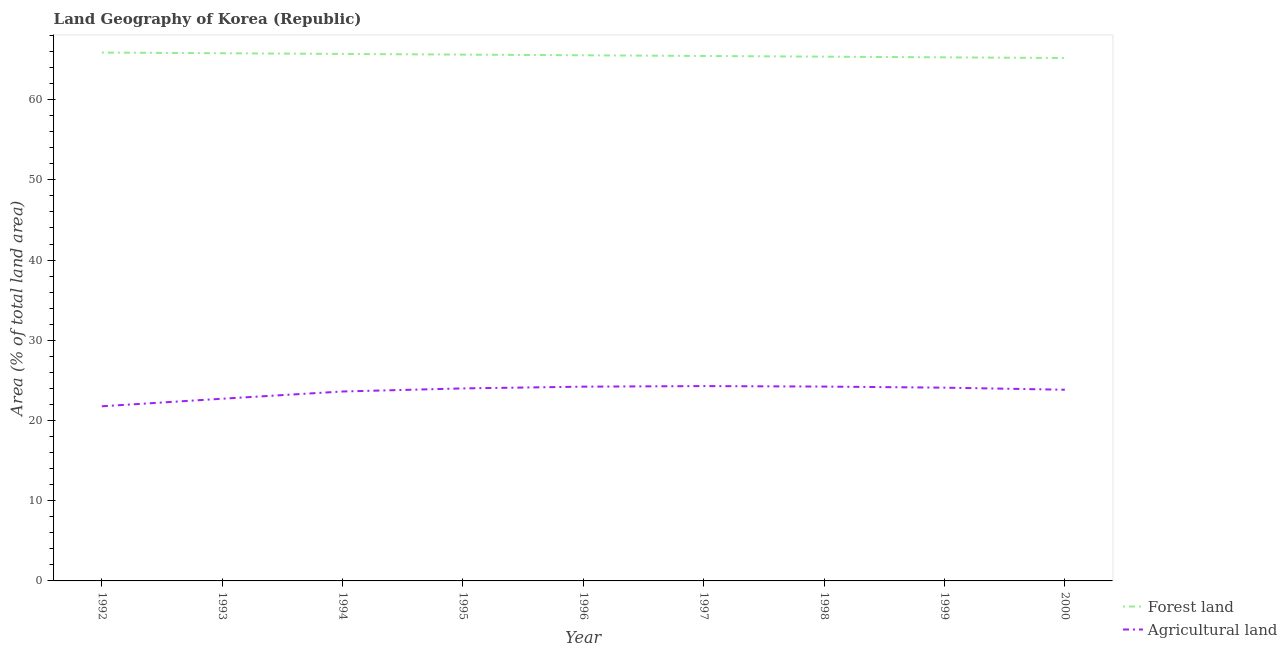How many different coloured lines are there?
Keep it short and to the point. 2. What is the percentage of land area under agriculture in 1994?
Provide a succinct answer. 23.62. Across all years, what is the maximum percentage of land area under forests?
Offer a terse response. 65.87. Across all years, what is the minimum percentage of land area under forests?
Ensure brevity in your answer.  65.19. In which year was the percentage of land area under agriculture minimum?
Your answer should be compact. 1992. What is the total percentage of land area under agriculture in the graph?
Offer a terse response. 212.76. What is the difference between the percentage of land area under agriculture in 1996 and that in 2000?
Ensure brevity in your answer.  0.38. What is the difference between the percentage of land area under agriculture in 1994 and the percentage of land area under forests in 1997?
Make the answer very short. -41.83. What is the average percentage of land area under agriculture per year?
Offer a very short reply. 23.64. In the year 2000, what is the difference between the percentage of land area under agriculture and percentage of land area under forests?
Your response must be concise. -41.35. What is the ratio of the percentage of land area under forests in 1997 to that in 1999?
Make the answer very short. 1. Is the percentage of land area under agriculture in 1993 less than that in 1999?
Provide a succinct answer. Yes. Is the difference between the percentage of land area under forests in 1999 and 2000 greater than the difference between the percentage of land area under agriculture in 1999 and 2000?
Ensure brevity in your answer.  No. What is the difference between the highest and the second highest percentage of land area under forests?
Your response must be concise. 0.09. What is the difference between the highest and the lowest percentage of land area under agriculture?
Offer a very short reply. 2.52. In how many years, is the percentage of land area under agriculture greater than the average percentage of land area under agriculture taken over all years?
Offer a very short reply. 6. Does the percentage of land area under agriculture monotonically increase over the years?
Provide a short and direct response. No. Is the percentage of land area under forests strictly greater than the percentage of land area under agriculture over the years?
Provide a short and direct response. Yes. Is the percentage of land area under forests strictly less than the percentage of land area under agriculture over the years?
Your answer should be very brief. No. Are the values on the major ticks of Y-axis written in scientific E-notation?
Your response must be concise. No. Does the graph contain any zero values?
Make the answer very short. No. Does the graph contain grids?
Your answer should be compact. No. Where does the legend appear in the graph?
Keep it short and to the point. Bottom right. What is the title of the graph?
Provide a succinct answer. Land Geography of Korea (Republic). Does "Stunting" appear as one of the legend labels in the graph?
Make the answer very short. No. What is the label or title of the Y-axis?
Give a very brief answer. Area (% of total land area). What is the Area (% of total land area) of Forest land in 1992?
Make the answer very short. 65.87. What is the Area (% of total land area) of Agricultural land in 1992?
Your response must be concise. 21.77. What is the Area (% of total land area) of Forest land in 1993?
Your answer should be compact. 65.78. What is the Area (% of total land area) of Agricultural land in 1993?
Your response must be concise. 22.71. What is the Area (% of total land area) of Forest land in 1994?
Provide a short and direct response. 65.7. What is the Area (% of total land area) of Agricultural land in 1994?
Offer a terse response. 23.62. What is the Area (% of total land area) of Forest land in 1995?
Your answer should be very brief. 65.61. What is the Area (% of total land area) of Agricultural land in 1995?
Your answer should be compact. 24. What is the Area (% of total land area) in Forest land in 1996?
Make the answer very short. 65.53. What is the Area (% of total land area) in Agricultural land in 1996?
Ensure brevity in your answer.  24.22. What is the Area (% of total land area) of Forest land in 1997?
Provide a succinct answer. 65.44. What is the Area (% of total land area) in Agricultural land in 1997?
Your response must be concise. 24.29. What is the Area (% of total land area) of Forest land in 1998?
Provide a succinct answer. 65.36. What is the Area (% of total land area) in Agricultural land in 1998?
Provide a succinct answer. 24.23. What is the Area (% of total land area) in Forest land in 1999?
Your answer should be very brief. 65.27. What is the Area (% of total land area) of Agricultural land in 1999?
Provide a short and direct response. 24.09. What is the Area (% of total land area) in Forest land in 2000?
Keep it short and to the point. 65.19. What is the Area (% of total land area) of Agricultural land in 2000?
Keep it short and to the point. 23.83. Across all years, what is the maximum Area (% of total land area) in Forest land?
Your answer should be compact. 65.87. Across all years, what is the maximum Area (% of total land area) in Agricultural land?
Give a very brief answer. 24.29. Across all years, what is the minimum Area (% of total land area) in Forest land?
Provide a succinct answer. 65.19. Across all years, what is the minimum Area (% of total land area) of Agricultural land?
Your answer should be compact. 21.77. What is the total Area (% of total land area) in Forest land in the graph?
Ensure brevity in your answer.  589.75. What is the total Area (% of total land area) of Agricultural land in the graph?
Offer a terse response. 212.76. What is the difference between the Area (% of total land area) in Forest land in 1992 and that in 1993?
Provide a short and direct response. 0.09. What is the difference between the Area (% of total land area) in Agricultural land in 1992 and that in 1993?
Make the answer very short. -0.94. What is the difference between the Area (% of total land area) in Forest land in 1992 and that in 1994?
Offer a very short reply. 0.17. What is the difference between the Area (% of total land area) in Agricultural land in 1992 and that in 1994?
Your answer should be very brief. -1.85. What is the difference between the Area (% of total land area) of Forest land in 1992 and that in 1995?
Offer a very short reply. 0.26. What is the difference between the Area (% of total land area) in Agricultural land in 1992 and that in 1995?
Your answer should be compact. -2.23. What is the difference between the Area (% of total land area) of Forest land in 1992 and that in 1996?
Your response must be concise. 0.34. What is the difference between the Area (% of total land area) in Agricultural land in 1992 and that in 1996?
Your answer should be compact. -2.45. What is the difference between the Area (% of total land area) of Forest land in 1992 and that in 1997?
Your answer should be compact. 0.42. What is the difference between the Area (% of total land area) of Agricultural land in 1992 and that in 1997?
Provide a short and direct response. -2.52. What is the difference between the Area (% of total land area) of Forest land in 1992 and that in 1998?
Your answer should be compact. 0.51. What is the difference between the Area (% of total land area) in Agricultural land in 1992 and that in 1998?
Your answer should be compact. -2.46. What is the difference between the Area (% of total land area) in Forest land in 1992 and that in 1999?
Ensure brevity in your answer.  0.6. What is the difference between the Area (% of total land area) in Agricultural land in 1992 and that in 1999?
Your response must be concise. -2.32. What is the difference between the Area (% of total land area) of Forest land in 1992 and that in 2000?
Provide a succinct answer. 0.68. What is the difference between the Area (% of total land area) of Agricultural land in 1992 and that in 2000?
Provide a short and direct response. -2.06. What is the difference between the Area (% of total land area) in Forest land in 1993 and that in 1994?
Give a very brief answer. 0.09. What is the difference between the Area (% of total land area) in Agricultural land in 1993 and that in 1994?
Offer a very short reply. -0.9. What is the difference between the Area (% of total land area) in Forest land in 1993 and that in 1995?
Your response must be concise. 0.17. What is the difference between the Area (% of total land area) in Agricultural land in 1993 and that in 1995?
Keep it short and to the point. -1.29. What is the difference between the Area (% of total land area) of Forest land in 1993 and that in 1996?
Keep it short and to the point. 0.26. What is the difference between the Area (% of total land area) in Agricultural land in 1993 and that in 1996?
Offer a terse response. -1.5. What is the difference between the Area (% of total land area) in Forest land in 1993 and that in 1997?
Your answer should be very brief. 0.34. What is the difference between the Area (% of total land area) in Agricultural land in 1993 and that in 1997?
Offer a very short reply. -1.58. What is the difference between the Area (% of total land area) in Forest land in 1993 and that in 1998?
Offer a terse response. 0.42. What is the difference between the Area (% of total land area) in Agricultural land in 1993 and that in 1998?
Keep it short and to the point. -1.51. What is the difference between the Area (% of total land area) in Forest land in 1993 and that in 1999?
Make the answer very short. 0.51. What is the difference between the Area (% of total land area) in Agricultural land in 1993 and that in 1999?
Make the answer very short. -1.38. What is the difference between the Area (% of total land area) in Forest land in 1993 and that in 2000?
Give a very brief answer. 0.6. What is the difference between the Area (% of total land area) of Agricultural land in 1993 and that in 2000?
Keep it short and to the point. -1.12. What is the difference between the Area (% of total land area) of Forest land in 1994 and that in 1995?
Provide a short and direct response. 0.09. What is the difference between the Area (% of total land area) of Agricultural land in 1994 and that in 1995?
Keep it short and to the point. -0.38. What is the difference between the Area (% of total land area) in Forest land in 1994 and that in 1996?
Give a very brief answer. 0.17. What is the difference between the Area (% of total land area) of Agricultural land in 1994 and that in 1996?
Your answer should be very brief. -0.6. What is the difference between the Area (% of total land area) of Forest land in 1994 and that in 1997?
Offer a very short reply. 0.26. What is the difference between the Area (% of total land area) of Agricultural land in 1994 and that in 1997?
Provide a short and direct response. -0.67. What is the difference between the Area (% of total land area) of Forest land in 1994 and that in 1998?
Make the answer very short. 0.34. What is the difference between the Area (% of total land area) in Agricultural land in 1994 and that in 1998?
Provide a succinct answer. -0.61. What is the difference between the Area (% of total land area) of Forest land in 1994 and that in 1999?
Give a very brief answer. 0.42. What is the difference between the Area (% of total land area) in Agricultural land in 1994 and that in 1999?
Your response must be concise. -0.48. What is the difference between the Area (% of total land area) in Forest land in 1994 and that in 2000?
Your response must be concise. 0.51. What is the difference between the Area (% of total land area) in Agricultural land in 1994 and that in 2000?
Your answer should be very brief. -0.22. What is the difference between the Area (% of total land area) of Forest land in 1995 and that in 1996?
Give a very brief answer. 0.09. What is the difference between the Area (% of total land area) in Agricultural land in 1995 and that in 1996?
Provide a short and direct response. -0.22. What is the difference between the Area (% of total land area) of Forest land in 1995 and that in 1997?
Provide a succinct answer. 0.17. What is the difference between the Area (% of total land area) of Agricultural land in 1995 and that in 1997?
Ensure brevity in your answer.  -0.29. What is the difference between the Area (% of total land area) of Forest land in 1995 and that in 1998?
Your answer should be very brief. 0.26. What is the difference between the Area (% of total land area) in Agricultural land in 1995 and that in 1998?
Your answer should be very brief. -0.23. What is the difference between the Area (% of total land area) in Forest land in 1995 and that in 1999?
Offer a terse response. 0.34. What is the difference between the Area (% of total land area) of Agricultural land in 1995 and that in 1999?
Keep it short and to the point. -0.09. What is the difference between the Area (% of total land area) in Forest land in 1995 and that in 2000?
Your answer should be very brief. 0.42. What is the difference between the Area (% of total land area) in Agricultural land in 1995 and that in 2000?
Your response must be concise. 0.17. What is the difference between the Area (% of total land area) in Forest land in 1996 and that in 1997?
Make the answer very short. 0.09. What is the difference between the Area (% of total land area) of Agricultural land in 1996 and that in 1997?
Your response must be concise. -0.07. What is the difference between the Area (% of total land area) of Forest land in 1996 and that in 1998?
Offer a very short reply. 0.17. What is the difference between the Area (% of total land area) in Agricultural land in 1996 and that in 1998?
Offer a terse response. -0.01. What is the difference between the Area (% of total land area) in Forest land in 1996 and that in 1999?
Your answer should be very brief. 0.26. What is the difference between the Area (% of total land area) in Agricultural land in 1996 and that in 1999?
Keep it short and to the point. 0.12. What is the difference between the Area (% of total land area) in Forest land in 1996 and that in 2000?
Your answer should be very brief. 0.34. What is the difference between the Area (% of total land area) in Agricultural land in 1996 and that in 2000?
Your answer should be compact. 0.38. What is the difference between the Area (% of total land area) in Forest land in 1997 and that in 1998?
Provide a succinct answer. 0.09. What is the difference between the Area (% of total land area) in Agricultural land in 1997 and that in 1998?
Give a very brief answer. 0.06. What is the difference between the Area (% of total land area) of Forest land in 1997 and that in 1999?
Give a very brief answer. 0.17. What is the difference between the Area (% of total land area) of Agricultural land in 1997 and that in 1999?
Make the answer very short. 0.2. What is the difference between the Area (% of total land area) in Forest land in 1997 and that in 2000?
Make the answer very short. 0.26. What is the difference between the Area (% of total land area) in Agricultural land in 1997 and that in 2000?
Ensure brevity in your answer.  0.46. What is the difference between the Area (% of total land area) of Forest land in 1998 and that in 1999?
Your answer should be compact. 0.09. What is the difference between the Area (% of total land area) of Agricultural land in 1998 and that in 1999?
Keep it short and to the point. 0.13. What is the difference between the Area (% of total land area) of Forest land in 1998 and that in 2000?
Offer a terse response. 0.17. What is the difference between the Area (% of total land area) in Agricultural land in 1998 and that in 2000?
Make the answer very short. 0.39. What is the difference between the Area (% of total land area) of Forest land in 1999 and that in 2000?
Your answer should be compact. 0.09. What is the difference between the Area (% of total land area) in Agricultural land in 1999 and that in 2000?
Keep it short and to the point. 0.26. What is the difference between the Area (% of total land area) of Forest land in 1992 and the Area (% of total land area) of Agricultural land in 1993?
Your response must be concise. 43.15. What is the difference between the Area (% of total land area) in Forest land in 1992 and the Area (% of total land area) in Agricultural land in 1994?
Offer a terse response. 42.25. What is the difference between the Area (% of total land area) of Forest land in 1992 and the Area (% of total land area) of Agricultural land in 1995?
Offer a very short reply. 41.87. What is the difference between the Area (% of total land area) of Forest land in 1992 and the Area (% of total land area) of Agricultural land in 1996?
Your answer should be compact. 41.65. What is the difference between the Area (% of total land area) of Forest land in 1992 and the Area (% of total land area) of Agricultural land in 1997?
Your response must be concise. 41.58. What is the difference between the Area (% of total land area) of Forest land in 1992 and the Area (% of total land area) of Agricultural land in 1998?
Provide a succinct answer. 41.64. What is the difference between the Area (% of total land area) of Forest land in 1992 and the Area (% of total land area) of Agricultural land in 1999?
Your answer should be very brief. 41.77. What is the difference between the Area (% of total land area) in Forest land in 1992 and the Area (% of total land area) in Agricultural land in 2000?
Provide a succinct answer. 42.03. What is the difference between the Area (% of total land area) in Forest land in 1993 and the Area (% of total land area) in Agricultural land in 1994?
Your answer should be compact. 42.17. What is the difference between the Area (% of total land area) in Forest land in 1993 and the Area (% of total land area) in Agricultural land in 1995?
Make the answer very short. 41.78. What is the difference between the Area (% of total land area) in Forest land in 1993 and the Area (% of total land area) in Agricultural land in 1996?
Your response must be concise. 41.57. What is the difference between the Area (% of total land area) in Forest land in 1993 and the Area (% of total land area) in Agricultural land in 1997?
Ensure brevity in your answer.  41.49. What is the difference between the Area (% of total land area) of Forest land in 1993 and the Area (% of total land area) of Agricultural land in 1998?
Provide a succinct answer. 41.55. What is the difference between the Area (% of total land area) of Forest land in 1993 and the Area (% of total land area) of Agricultural land in 1999?
Your answer should be very brief. 41.69. What is the difference between the Area (% of total land area) in Forest land in 1993 and the Area (% of total land area) in Agricultural land in 2000?
Give a very brief answer. 41.95. What is the difference between the Area (% of total land area) in Forest land in 1994 and the Area (% of total land area) in Agricultural land in 1995?
Offer a terse response. 41.7. What is the difference between the Area (% of total land area) in Forest land in 1994 and the Area (% of total land area) in Agricultural land in 1996?
Your answer should be very brief. 41.48. What is the difference between the Area (% of total land area) in Forest land in 1994 and the Area (% of total land area) in Agricultural land in 1997?
Provide a short and direct response. 41.41. What is the difference between the Area (% of total land area) in Forest land in 1994 and the Area (% of total land area) in Agricultural land in 1998?
Provide a short and direct response. 41.47. What is the difference between the Area (% of total land area) in Forest land in 1994 and the Area (% of total land area) in Agricultural land in 1999?
Your answer should be compact. 41.6. What is the difference between the Area (% of total land area) of Forest land in 1994 and the Area (% of total land area) of Agricultural land in 2000?
Ensure brevity in your answer.  41.86. What is the difference between the Area (% of total land area) in Forest land in 1995 and the Area (% of total land area) in Agricultural land in 1996?
Your answer should be very brief. 41.4. What is the difference between the Area (% of total land area) of Forest land in 1995 and the Area (% of total land area) of Agricultural land in 1997?
Keep it short and to the point. 41.32. What is the difference between the Area (% of total land area) in Forest land in 1995 and the Area (% of total land area) in Agricultural land in 1998?
Give a very brief answer. 41.38. What is the difference between the Area (% of total land area) in Forest land in 1995 and the Area (% of total land area) in Agricultural land in 1999?
Your response must be concise. 41.52. What is the difference between the Area (% of total land area) of Forest land in 1995 and the Area (% of total land area) of Agricultural land in 2000?
Offer a terse response. 41.78. What is the difference between the Area (% of total land area) of Forest land in 1996 and the Area (% of total land area) of Agricultural land in 1997?
Your response must be concise. 41.24. What is the difference between the Area (% of total land area) in Forest land in 1996 and the Area (% of total land area) in Agricultural land in 1998?
Make the answer very short. 41.3. What is the difference between the Area (% of total land area) of Forest land in 1996 and the Area (% of total land area) of Agricultural land in 1999?
Provide a succinct answer. 41.43. What is the difference between the Area (% of total land area) in Forest land in 1996 and the Area (% of total land area) in Agricultural land in 2000?
Make the answer very short. 41.69. What is the difference between the Area (% of total land area) in Forest land in 1997 and the Area (% of total land area) in Agricultural land in 1998?
Keep it short and to the point. 41.22. What is the difference between the Area (% of total land area) in Forest land in 1997 and the Area (% of total land area) in Agricultural land in 1999?
Offer a terse response. 41.35. What is the difference between the Area (% of total land area) of Forest land in 1997 and the Area (% of total land area) of Agricultural land in 2000?
Offer a very short reply. 41.61. What is the difference between the Area (% of total land area) in Forest land in 1998 and the Area (% of total land area) in Agricultural land in 1999?
Ensure brevity in your answer.  41.26. What is the difference between the Area (% of total land area) of Forest land in 1998 and the Area (% of total land area) of Agricultural land in 2000?
Ensure brevity in your answer.  41.52. What is the difference between the Area (% of total land area) in Forest land in 1999 and the Area (% of total land area) in Agricultural land in 2000?
Your response must be concise. 41.44. What is the average Area (% of total land area) in Forest land per year?
Keep it short and to the point. 65.53. What is the average Area (% of total land area) of Agricultural land per year?
Make the answer very short. 23.64. In the year 1992, what is the difference between the Area (% of total land area) of Forest land and Area (% of total land area) of Agricultural land?
Give a very brief answer. 44.1. In the year 1993, what is the difference between the Area (% of total land area) of Forest land and Area (% of total land area) of Agricultural land?
Ensure brevity in your answer.  43.07. In the year 1994, what is the difference between the Area (% of total land area) in Forest land and Area (% of total land area) in Agricultural land?
Your answer should be compact. 42.08. In the year 1995, what is the difference between the Area (% of total land area) of Forest land and Area (% of total land area) of Agricultural land?
Ensure brevity in your answer.  41.61. In the year 1996, what is the difference between the Area (% of total land area) of Forest land and Area (% of total land area) of Agricultural land?
Give a very brief answer. 41.31. In the year 1997, what is the difference between the Area (% of total land area) of Forest land and Area (% of total land area) of Agricultural land?
Keep it short and to the point. 41.15. In the year 1998, what is the difference between the Area (% of total land area) of Forest land and Area (% of total land area) of Agricultural land?
Ensure brevity in your answer.  41.13. In the year 1999, what is the difference between the Area (% of total land area) of Forest land and Area (% of total land area) of Agricultural land?
Provide a short and direct response. 41.18. In the year 2000, what is the difference between the Area (% of total land area) of Forest land and Area (% of total land area) of Agricultural land?
Your answer should be compact. 41.35. What is the ratio of the Area (% of total land area) of Forest land in 1992 to that in 1993?
Offer a terse response. 1. What is the ratio of the Area (% of total land area) in Agricultural land in 1992 to that in 1993?
Ensure brevity in your answer.  0.96. What is the ratio of the Area (% of total land area) in Agricultural land in 1992 to that in 1994?
Keep it short and to the point. 0.92. What is the ratio of the Area (% of total land area) in Agricultural land in 1992 to that in 1995?
Offer a very short reply. 0.91. What is the ratio of the Area (% of total land area) of Agricultural land in 1992 to that in 1996?
Your answer should be compact. 0.9. What is the ratio of the Area (% of total land area) of Agricultural land in 1992 to that in 1997?
Offer a terse response. 0.9. What is the ratio of the Area (% of total land area) in Forest land in 1992 to that in 1998?
Offer a terse response. 1.01. What is the ratio of the Area (% of total land area) in Agricultural land in 1992 to that in 1998?
Offer a terse response. 0.9. What is the ratio of the Area (% of total land area) in Forest land in 1992 to that in 1999?
Offer a very short reply. 1.01. What is the ratio of the Area (% of total land area) of Agricultural land in 1992 to that in 1999?
Your answer should be compact. 0.9. What is the ratio of the Area (% of total land area) of Forest land in 1992 to that in 2000?
Your answer should be compact. 1.01. What is the ratio of the Area (% of total land area) of Agricultural land in 1992 to that in 2000?
Make the answer very short. 0.91. What is the ratio of the Area (% of total land area) in Agricultural land in 1993 to that in 1994?
Ensure brevity in your answer.  0.96. What is the ratio of the Area (% of total land area) of Agricultural land in 1993 to that in 1995?
Ensure brevity in your answer.  0.95. What is the ratio of the Area (% of total land area) of Forest land in 1993 to that in 1996?
Provide a succinct answer. 1. What is the ratio of the Area (% of total land area) in Agricultural land in 1993 to that in 1996?
Your answer should be compact. 0.94. What is the ratio of the Area (% of total land area) of Forest land in 1993 to that in 1997?
Offer a very short reply. 1.01. What is the ratio of the Area (% of total land area) of Agricultural land in 1993 to that in 1997?
Your response must be concise. 0.94. What is the ratio of the Area (% of total land area) of Forest land in 1993 to that in 1999?
Your answer should be compact. 1.01. What is the ratio of the Area (% of total land area) in Agricultural land in 1993 to that in 1999?
Your answer should be compact. 0.94. What is the ratio of the Area (% of total land area) of Forest land in 1993 to that in 2000?
Your answer should be compact. 1.01. What is the ratio of the Area (% of total land area) of Agricultural land in 1993 to that in 2000?
Make the answer very short. 0.95. What is the ratio of the Area (% of total land area) of Agricultural land in 1994 to that in 1996?
Offer a terse response. 0.98. What is the ratio of the Area (% of total land area) in Forest land in 1994 to that in 1997?
Provide a short and direct response. 1. What is the ratio of the Area (% of total land area) of Agricultural land in 1994 to that in 1997?
Make the answer very short. 0.97. What is the ratio of the Area (% of total land area) in Agricultural land in 1994 to that in 1998?
Your answer should be compact. 0.97. What is the ratio of the Area (% of total land area) of Agricultural land in 1994 to that in 1999?
Provide a succinct answer. 0.98. What is the ratio of the Area (% of total land area) in Forest land in 1994 to that in 2000?
Your answer should be very brief. 1.01. What is the ratio of the Area (% of total land area) in Agricultural land in 1994 to that in 2000?
Provide a short and direct response. 0.99. What is the ratio of the Area (% of total land area) of Forest land in 1995 to that in 1996?
Give a very brief answer. 1. What is the ratio of the Area (% of total land area) in Agricultural land in 1995 to that in 1996?
Your answer should be very brief. 0.99. What is the ratio of the Area (% of total land area) of Forest land in 1995 to that in 1997?
Your response must be concise. 1. What is the ratio of the Area (% of total land area) of Agricultural land in 1995 to that in 1997?
Give a very brief answer. 0.99. What is the ratio of the Area (% of total land area) of Forest land in 1995 to that in 1998?
Offer a very short reply. 1. What is the ratio of the Area (% of total land area) in Agricultural land in 1995 to that in 1998?
Keep it short and to the point. 0.99. What is the ratio of the Area (% of total land area) in Forest land in 1995 to that in 1999?
Ensure brevity in your answer.  1.01. What is the ratio of the Area (% of total land area) in Agricultural land in 1995 to that in 1999?
Provide a succinct answer. 1. What is the ratio of the Area (% of total land area) of Agricultural land in 1996 to that in 1998?
Your response must be concise. 1. What is the ratio of the Area (% of total land area) of Agricultural land in 1996 to that in 2000?
Offer a very short reply. 1.02. What is the ratio of the Area (% of total land area) in Agricultural land in 1997 to that in 1998?
Offer a terse response. 1. What is the ratio of the Area (% of total land area) in Forest land in 1997 to that in 1999?
Offer a terse response. 1. What is the ratio of the Area (% of total land area) of Agricultural land in 1997 to that in 1999?
Offer a terse response. 1.01. What is the ratio of the Area (% of total land area) of Agricultural land in 1997 to that in 2000?
Your response must be concise. 1.02. What is the ratio of the Area (% of total land area) in Agricultural land in 1998 to that in 1999?
Provide a succinct answer. 1.01. What is the ratio of the Area (% of total land area) of Forest land in 1998 to that in 2000?
Give a very brief answer. 1. What is the ratio of the Area (% of total land area) of Agricultural land in 1998 to that in 2000?
Offer a terse response. 1.02. What is the ratio of the Area (% of total land area) in Forest land in 1999 to that in 2000?
Offer a very short reply. 1. What is the ratio of the Area (% of total land area) of Agricultural land in 1999 to that in 2000?
Provide a succinct answer. 1.01. What is the difference between the highest and the second highest Area (% of total land area) of Forest land?
Your response must be concise. 0.09. What is the difference between the highest and the second highest Area (% of total land area) of Agricultural land?
Make the answer very short. 0.06. What is the difference between the highest and the lowest Area (% of total land area) of Forest land?
Give a very brief answer. 0.68. What is the difference between the highest and the lowest Area (% of total land area) of Agricultural land?
Offer a very short reply. 2.52. 